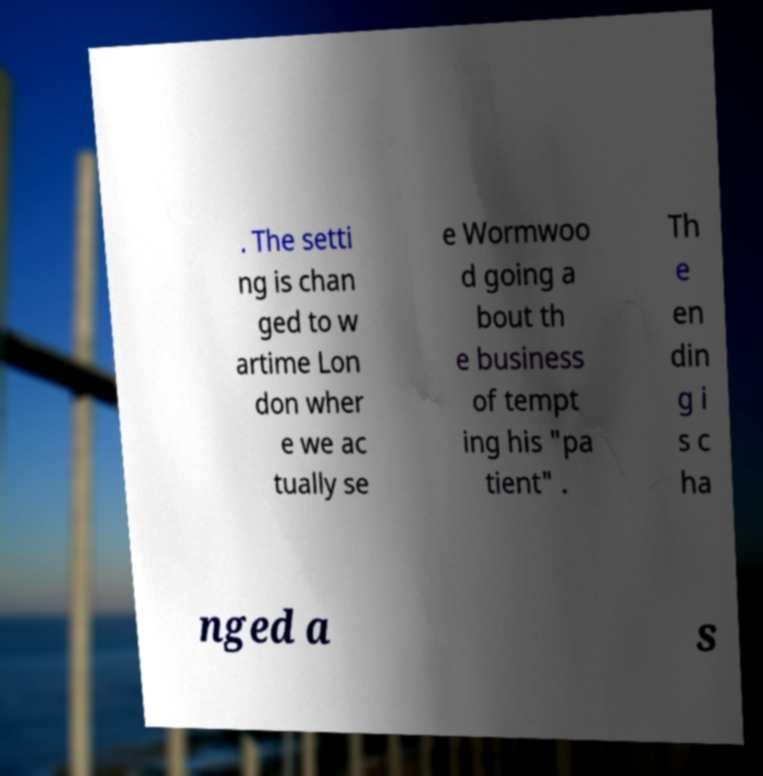What messages or text are displayed in this image? I need them in a readable, typed format. . The setti ng is chan ged to w artime Lon don wher e we ac tually se e Wormwoo d going a bout th e business of tempt ing his "pa tient" . Th e en din g i s c ha nged a s 